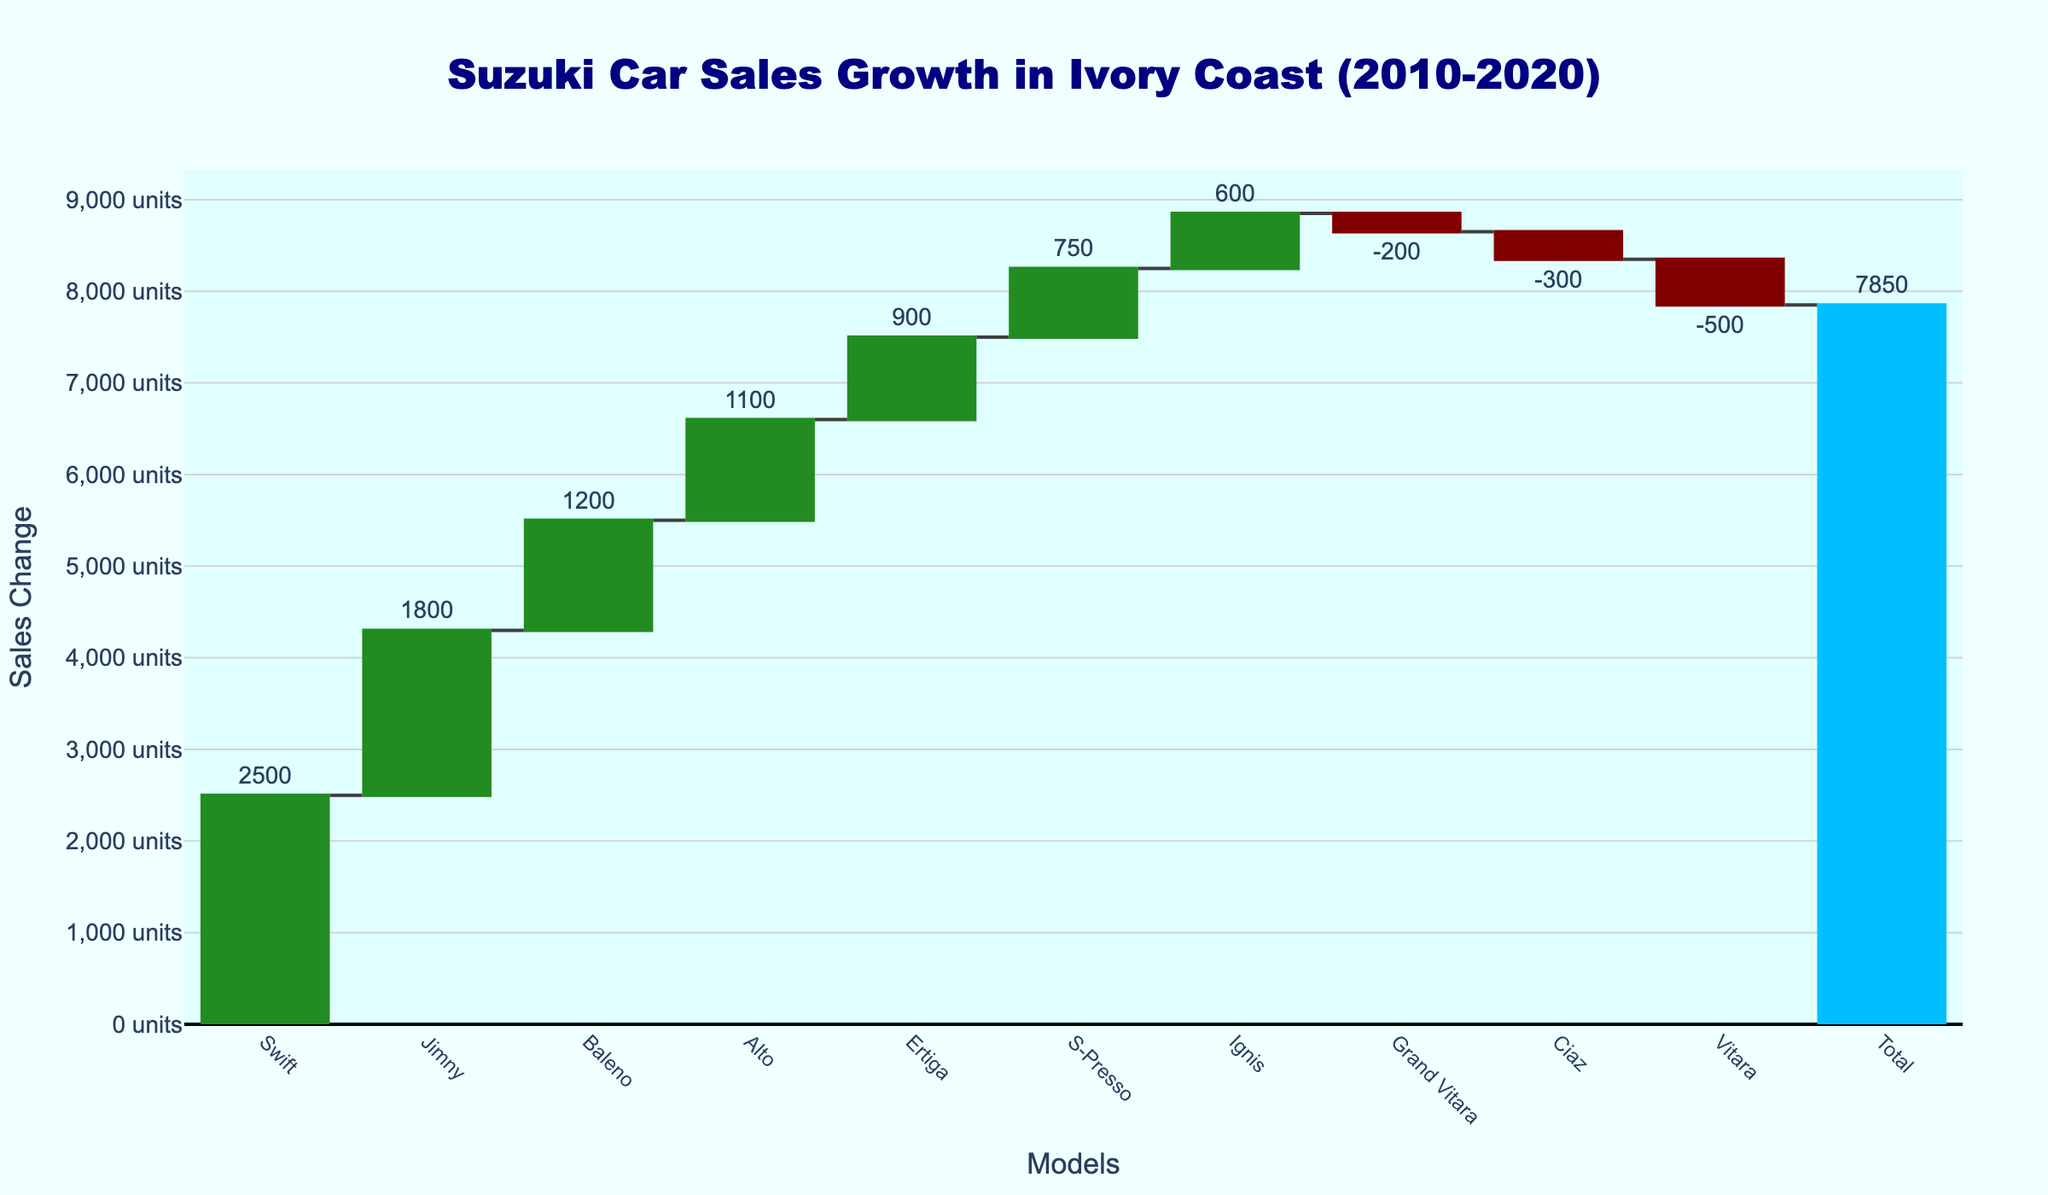How many Suzuki models showed a positive sales change from 2010 to 2020? To determine the number of Suzuki models with a positive sales change, count the models with bars in green color (indicating increased sales). There are Swift, Jimny, Baleno, Ertiga, S-Presso, Ignis, and Alto.
Answer: 7 Which model contributed the most to the sales increase? The model with the tallest green bar represents the highest positive sales change. That is the Swift model.
Answer: Swift What is the sales change for the Vitara model? Find the height and color of the bar representing the Vitara model. The bar is maroon and marked with -500, indicating a sales decrease of 500 units.
Answer: -500 Which models showed a decrease in sales? Count the models depicted with maroon bars, which represent sales decreases. The models are Vitara, Ciaz, and Grand Vitara.
Answer: Vitara, Ciaz, Grand Vitara What is the combined sales increase for the Swift and Jimny models? Add the sales change values for Swift and Jimny. The Swift sales changed by 2500 units and the Jimny by 1800 units, totaling 2500 + 1800.
Answer: 4300 How does the sales change for the Swift compare to the Alto? Review the sales change values for the Swift and Alto. Swift has 2500 units and Alto has 1100 units. Swift's sales increase is greater than Alto’s.
Answer: Greater than What is the total change in sales across all models? Look at the final bar labeled 'Total' at the end of the chart. It shows the sum of all individual changes, which is 7850 units.
Answer: 7850 Which model had the lowest positive sales change? Among the green bars, identify the one with the smallest value. The S-Presso model has the smallest increase with 750 units.
Answer: S-Presso How does the decrease in sales for the Ciaz compare to the Grand Vitara? Compare the sales change values. Ciaz decreased by 300 units, and Grand Vitara by 200 units. Ciaz had a greater decrease than Grand Vitara.
Answer: Greater than Which four models showed the highest positive sales change? Identify the four tallest green bars, representing the largest increases. They correspond to Swift, Jimny, Baleno, and Alto.
Answer: Swift, Jimny, Baleno, Alto 